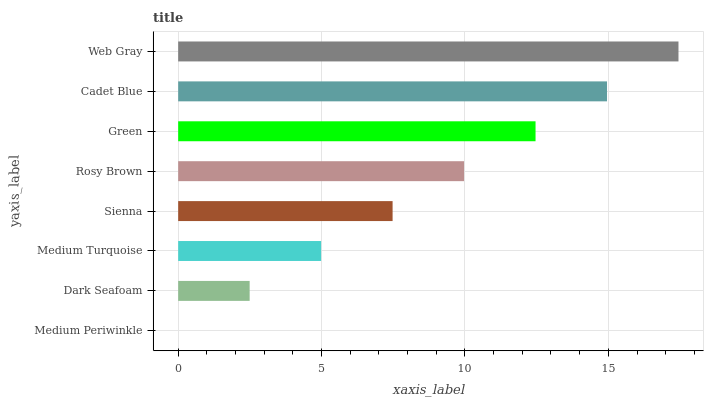Is Medium Periwinkle the minimum?
Answer yes or no. Yes. Is Web Gray the maximum?
Answer yes or no. Yes. Is Dark Seafoam the minimum?
Answer yes or no. No. Is Dark Seafoam the maximum?
Answer yes or no. No. Is Dark Seafoam greater than Medium Periwinkle?
Answer yes or no. Yes. Is Medium Periwinkle less than Dark Seafoam?
Answer yes or no. Yes. Is Medium Periwinkle greater than Dark Seafoam?
Answer yes or no. No. Is Dark Seafoam less than Medium Periwinkle?
Answer yes or no. No. Is Rosy Brown the high median?
Answer yes or no. Yes. Is Sienna the low median?
Answer yes or no. Yes. Is Sienna the high median?
Answer yes or no. No. Is Green the low median?
Answer yes or no. No. 